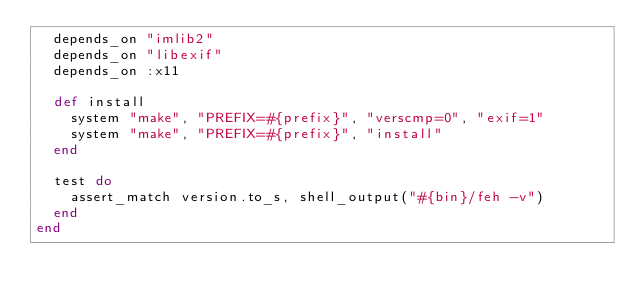Convert code to text. <code><loc_0><loc_0><loc_500><loc_500><_Ruby_>  depends_on "imlib2"
  depends_on "libexif"
  depends_on :x11

  def install
    system "make", "PREFIX=#{prefix}", "verscmp=0", "exif=1"
    system "make", "PREFIX=#{prefix}", "install"
  end

  test do
    assert_match version.to_s, shell_output("#{bin}/feh -v")
  end
end
</code> 